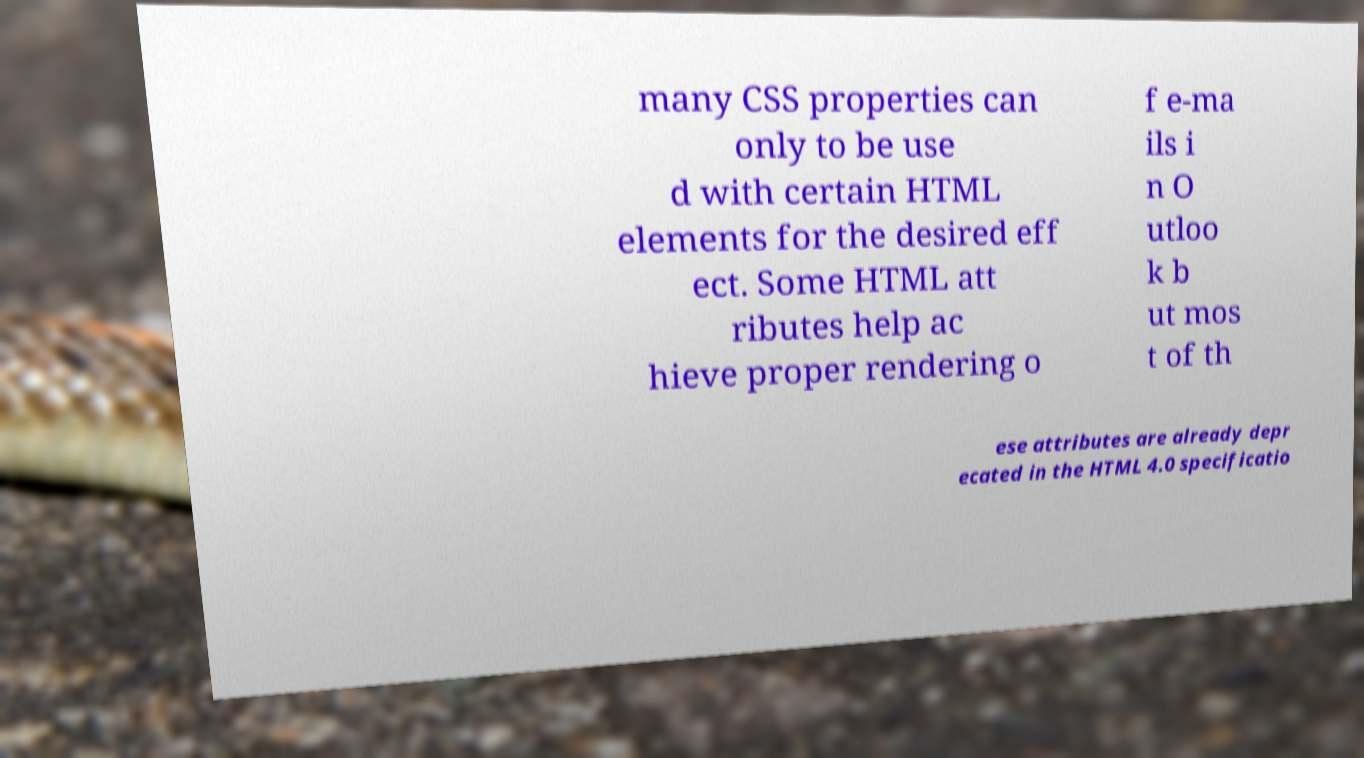I need the written content from this picture converted into text. Can you do that? many CSS properties can only to be use d with certain HTML elements for the desired eff ect. Some HTML att ributes help ac hieve proper rendering o f e-ma ils i n O utloo k b ut mos t of th ese attributes are already depr ecated in the HTML 4.0 specificatio 